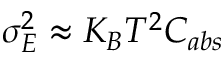Convert formula to latex. <formula><loc_0><loc_0><loc_500><loc_500>\sigma _ { E } ^ { 2 } \approx K _ { B } T ^ { 2 } C _ { a b s }</formula> 